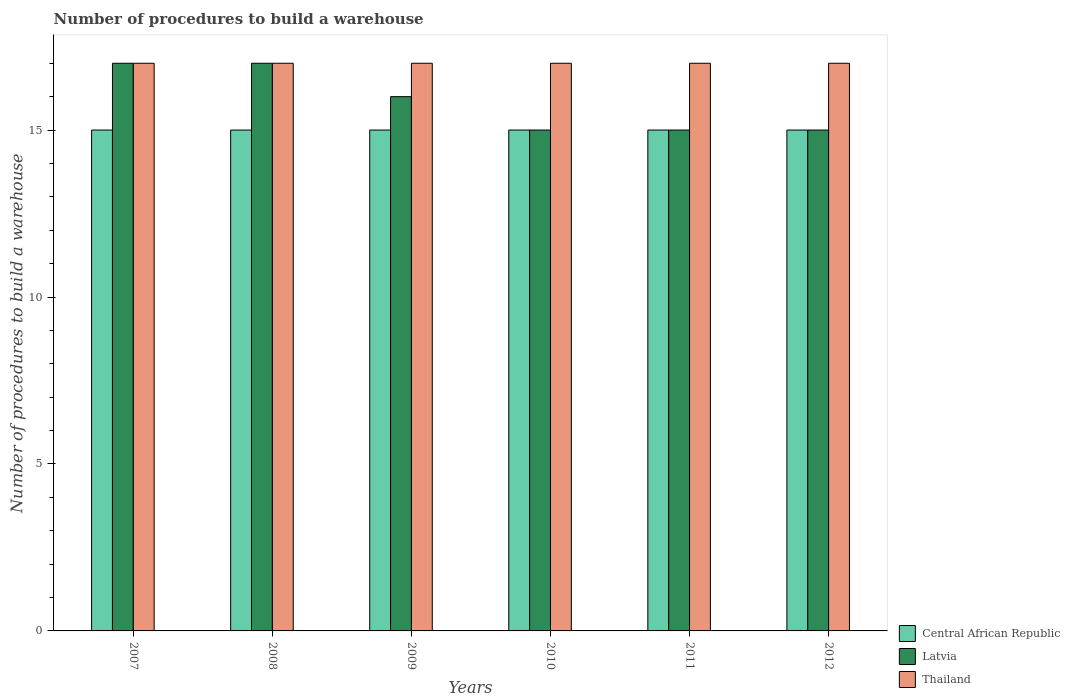How many groups of bars are there?
Ensure brevity in your answer.  6. How many bars are there on the 3rd tick from the left?
Provide a short and direct response. 3. In how many cases, is the number of bars for a given year not equal to the number of legend labels?
Offer a very short reply. 0. What is the number of procedures to build a warehouse in in Thailand in 2008?
Provide a succinct answer. 17. Across all years, what is the maximum number of procedures to build a warehouse in in Central African Republic?
Your answer should be very brief. 15. Across all years, what is the minimum number of procedures to build a warehouse in in Latvia?
Keep it short and to the point. 15. In which year was the number of procedures to build a warehouse in in Central African Republic maximum?
Provide a succinct answer. 2007. What is the total number of procedures to build a warehouse in in Central African Republic in the graph?
Your answer should be very brief. 90. What is the difference between the number of procedures to build a warehouse in in Thailand in 2007 and that in 2009?
Give a very brief answer. 0. What is the difference between the number of procedures to build a warehouse in in Latvia in 2011 and the number of procedures to build a warehouse in in Thailand in 2010?
Make the answer very short. -2. What is the average number of procedures to build a warehouse in in Latvia per year?
Provide a succinct answer. 15.83. In the year 2012, what is the difference between the number of procedures to build a warehouse in in Thailand and number of procedures to build a warehouse in in Latvia?
Make the answer very short. 2. Is the number of procedures to build a warehouse in in Latvia in 2008 less than that in 2009?
Give a very brief answer. No. Is the difference between the number of procedures to build a warehouse in in Thailand in 2011 and 2012 greater than the difference between the number of procedures to build a warehouse in in Latvia in 2011 and 2012?
Your answer should be very brief. No. What is the difference between the highest and the second highest number of procedures to build a warehouse in in Thailand?
Ensure brevity in your answer.  0. What is the difference between the highest and the lowest number of procedures to build a warehouse in in Thailand?
Offer a terse response. 0. What does the 3rd bar from the left in 2009 represents?
Your answer should be compact. Thailand. What does the 1st bar from the right in 2007 represents?
Ensure brevity in your answer.  Thailand. Is it the case that in every year, the sum of the number of procedures to build a warehouse in in Thailand and number of procedures to build a warehouse in in Central African Republic is greater than the number of procedures to build a warehouse in in Latvia?
Your answer should be compact. Yes. How many bars are there?
Offer a very short reply. 18. Are all the bars in the graph horizontal?
Ensure brevity in your answer.  No. Are the values on the major ticks of Y-axis written in scientific E-notation?
Your answer should be very brief. No. Where does the legend appear in the graph?
Make the answer very short. Bottom right. How many legend labels are there?
Provide a succinct answer. 3. What is the title of the graph?
Provide a short and direct response. Number of procedures to build a warehouse. What is the label or title of the Y-axis?
Make the answer very short. Number of procedures to build a warehouse. What is the Number of procedures to build a warehouse of Central African Republic in 2007?
Keep it short and to the point. 15. What is the Number of procedures to build a warehouse in Thailand in 2007?
Give a very brief answer. 17. What is the Number of procedures to build a warehouse in Central African Republic in 2009?
Provide a short and direct response. 15. What is the Number of procedures to build a warehouse in Thailand in 2009?
Make the answer very short. 17. What is the Number of procedures to build a warehouse in Latvia in 2011?
Ensure brevity in your answer.  15. What is the Number of procedures to build a warehouse of Thailand in 2011?
Keep it short and to the point. 17. What is the Number of procedures to build a warehouse in Latvia in 2012?
Provide a succinct answer. 15. What is the Number of procedures to build a warehouse in Thailand in 2012?
Ensure brevity in your answer.  17. Across all years, what is the maximum Number of procedures to build a warehouse of Central African Republic?
Provide a succinct answer. 15. Across all years, what is the minimum Number of procedures to build a warehouse in Thailand?
Your answer should be very brief. 17. What is the total Number of procedures to build a warehouse in Central African Republic in the graph?
Provide a succinct answer. 90. What is the total Number of procedures to build a warehouse of Latvia in the graph?
Give a very brief answer. 95. What is the total Number of procedures to build a warehouse in Thailand in the graph?
Ensure brevity in your answer.  102. What is the difference between the Number of procedures to build a warehouse in Latvia in 2007 and that in 2008?
Give a very brief answer. 0. What is the difference between the Number of procedures to build a warehouse in Thailand in 2007 and that in 2008?
Keep it short and to the point. 0. What is the difference between the Number of procedures to build a warehouse of Central African Republic in 2007 and that in 2009?
Offer a terse response. 0. What is the difference between the Number of procedures to build a warehouse in Latvia in 2007 and that in 2009?
Your answer should be very brief. 1. What is the difference between the Number of procedures to build a warehouse in Central African Republic in 2007 and that in 2010?
Ensure brevity in your answer.  0. What is the difference between the Number of procedures to build a warehouse of Latvia in 2007 and that in 2010?
Make the answer very short. 2. What is the difference between the Number of procedures to build a warehouse of Central African Republic in 2007 and that in 2011?
Provide a succinct answer. 0. What is the difference between the Number of procedures to build a warehouse of Thailand in 2007 and that in 2011?
Provide a succinct answer. 0. What is the difference between the Number of procedures to build a warehouse of Thailand in 2007 and that in 2012?
Your answer should be very brief. 0. What is the difference between the Number of procedures to build a warehouse of Latvia in 2008 and that in 2009?
Make the answer very short. 1. What is the difference between the Number of procedures to build a warehouse in Latvia in 2008 and that in 2011?
Keep it short and to the point. 2. What is the difference between the Number of procedures to build a warehouse in Latvia in 2008 and that in 2012?
Offer a terse response. 2. What is the difference between the Number of procedures to build a warehouse in Thailand in 2008 and that in 2012?
Provide a succinct answer. 0. What is the difference between the Number of procedures to build a warehouse in Latvia in 2009 and that in 2010?
Give a very brief answer. 1. What is the difference between the Number of procedures to build a warehouse in Thailand in 2009 and that in 2010?
Your response must be concise. 0. What is the difference between the Number of procedures to build a warehouse in Central African Republic in 2009 and that in 2011?
Offer a terse response. 0. What is the difference between the Number of procedures to build a warehouse in Thailand in 2009 and that in 2011?
Offer a very short reply. 0. What is the difference between the Number of procedures to build a warehouse in Latvia in 2009 and that in 2012?
Keep it short and to the point. 1. What is the difference between the Number of procedures to build a warehouse in Thailand in 2009 and that in 2012?
Offer a very short reply. 0. What is the difference between the Number of procedures to build a warehouse in Latvia in 2010 and that in 2011?
Your answer should be compact. 0. What is the difference between the Number of procedures to build a warehouse of Central African Republic in 2011 and that in 2012?
Offer a terse response. 0. What is the difference between the Number of procedures to build a warehouse in Latvia in 2011 and that in 2012?
Make the answer very short. 0. What is the difference between the Number of procedures to build a warehouse of Central African Republic in 2007 and the Number of procedures to build a warehouse of Thailand in 2008?
Offer a very short reply. -2. What is the difference between the Number of procedures to build a warehouse in Latvia in 2007 and the Number of procedures to build a warehouse in Thailand in 2009?
Give a very brief answer. 0. What is the difference between the Number of procedures to build a warehouse of Central African Republic in 2007 and the Number of procedures to build a warehouse of Latvia in 2011?
Offer a terse response. 0. What is the difference between the Number of procedures to build a warehouse of Central African Republic in 2007 and the Number of procedures to build a warehouse of Thailand in 2012?
Your response must be concise. -2. What is the difference between the Number of procedures to build a warehouse of Central African Republic in 2008 and the Number of procedures to build a warehouse of Latvia in 2009?
Your answer should be compact. -1. What is the difference between the Number of procedures to build a warehouse of Central African Republic in 2008 and the Number of procedures to build a warehouse of Thailand in 2009?
Offer a very short reply. -2. What is the difference between the Number of procedures to build a warehouse in Central African Republic in 2008 and the Number of procedures to build a warehouse in Latvia in 2010?
Offer a terse response. 0. What is the difference between the Number of procedures to build a warehouse of Central African Republic in 2008 and the Number of procedures to build a warehouse of Thailand in 2010?
Make the answer very short. -2. What is the difference between the Number of procedures to build a warehouse of Latvia in 2008 and the Number of procedures to build a warehouse of Thailand in 2010?
Make the answer very short. 0. What is the difference between the Number of procedures to build a warehouse in Latvia in 2008 and the Number of procedures to build a warehouse in Thailand in 2011?
Your response must be concise. 0. What is the difference between the Number of procedures to build a warehouse of Latvia in 2008 and the Number of procedures to build a warehouse of Thailand in 2012?
Provide a succinct answer. 0. What is the difference between the Number of procedures to build a warehouse in Central African Republic in 2009 and the Number of procedures to build a warehouse in Latvia in 2012?
Your answer should be very brief. 0. What is the difference between the Number of procedures to build a warehouse in Latvia in 2009 and the Number of procedures to build a warehouse in Thailand in 2012?
Make the answer very short. -1. What is the difference between the Number of procedures to build a warehouse of Latvia in 2010 and the Number of procedures to build a warehouse of Thailand in 2011?
Your answer should be very brief. -2. What is the difference between the Number of procedures to build a warehouse in Central African Republic in 2010 and the Number of procedures to build a warehouse in Latvia in 2012?
Ensure brevity in your answer.  0. What is the difference between the Number of procedures to build a warehouse of Central African Republic in 2011 and the Number of procedures to build a warehouse of Latvia in 2012?
Keep it short and to the point. 0. What is the difference between the Number of procedures to build a warehouse of Latvia in 2011 and the Number of procedures to build a warehouse of Thailand in 2012?
Give a very brief answer. -2. What is the average Number of procedures to build a warehouse of Latvia per year?
Offer a very short reply. 15.83. What is the average Number of procedures to build a warehouse of Thailand per year?
Your answer should be very brief. 17. In the year 2007, what is the difference between the Number of procedures to build a warehouse in Central African Republic and Number of procedures to build a warehouse in Latvia?
Provide a succinct answer. -2. In the year 2009, what is the difference between the Number of procedures to build a warehouse of Latvia and Number of procedures to build a warehouse of Thailand?
Offer a very short reply. -1. In the year 2011, what is the difference between the Number of procedures to build a warehouse in Central African Republic and Number of procedures to build a warehouse in Latvia?
Your response must be concise. 0. In the year 2011, what is the difference between the Number of procedures to build a warehouse in Central African Republic and Number of procedures to build a warehouse in Thailand?
Give a very brief answer. -2. In the year 2011, what is the difference between the Number of procedures to build a warehouse of Latvia and Number of procedures to build a warehouse of Thailand?
Provide a succinct answer. -2. In the year 2012, what is the difference between the Number of procedures to build a warehouse in Central African Republic and Number of procedures to build a warehouse in Latvia?
Give a very brief answer. 0. In the year 2012, what is the difference between the Number of procedures to build a warehouse of Latvia and Number of procedures to build a warehouse of Thailand?
Ensure brevity in your answer.  -2. What is the ratio of the Number of procedures to build a warehouse of Central African Republic in 2007 to that in 2008?
Provide a short and direct response. 1. What is the ratio of the Number of procedures to build a warehouse in Latvia in 2007 to that in 2008?
Your response must be concise. 1. What is the ratio of the Number of procedures to build a warehouse of Thailand in 2007 to that in 2008?
Ensure brevity in your answer.  1. What is the ratio of the Number of procedures to build a warehouse of Latvia in 2007 to that in 2009?
Your answer should be compact. 1.06. What is the ratio of the Number of procedures to build a warehouse in Thailand in 2007 to that in 2009?
Offer a terse response. 1. What is the ratio of the Number of procedures to build a warehouse in Central African Republic in 2007 to that in 2010?
Offer a very short reply. 1. What is the ratio of the Number of procedures to build a warehouse in Latvia in 2007 to that in 2010?
Provide a short and direct response. 1.13. What is the ratio of the Number of procedures to build a warehouse in Thailand in 2007 to that in 2010?
Your answer should be compact. 1. What is the ratio of the Number of procedures to build a warehouse in Central African Republic in 2007 to that in 2011?
Give a very brief answer. 1. What is the ratio of the Number of procedures to build a warehouse in Latvia in 2007 to that in 2011?
Make the answer very short. 1.13. What is the ratio of the Number of procedures to build a warehouse in Latvia in 2007 to that in 2012?
Your answer should be compact. 1.13. What is the ratio of the Number of procedures to build a warehouse in Thailand in 2007 to that in 2012?
Offer a very short reply. 1. What is the ratio of the Number of procedures to build a warehouse in Latvia in 2008 to that in 2010?
Your answer should be compact. 1.13. What is the ratio of the Number of procedures to build a warehouse in Latvia in 2008 to that in 2011?
Keep it short and to the point. 1.13. What is the ratio of the Number of procedures to build a warehouse of Thailand in 2008 to that in 2011?
Make the answer very short. 1. What is the ratio of the Number of procedures to build a warehouse of Latvia in 2008 to that in 2012?
Provide a succinct answer. 1.13. What is the ratio of the Number of procedures to build a warehouse of Thailand in 2008 to that in 2012?
Offer a very short reply. 1. What is the ratio of the Number of procedures to build a warehouse of Latvia in 2009 to that in 2010?
Your response must be concise. 1.07. What is the ratio of the Number of procedures to build a warehouse of Central African Republic in 2009 to that in 2011?
Keep it short and to the point. 1. What is the ratio of the Number of procedures to build a warehouse in Latvia in 2009 to that in 2011?
Make the answer very short. 1.07. What is the ratio of the Number of procedures to build a warehouse in Central African Republic in 2009 to that in 2012?
Provide a short and direct response. 1. What is the ratio of the Number of procedures to build a warehouse of Latvia in 2009 to that in 2012?
Make the answer very short. 1.07. What is the ratio of the Number of procedures to build a warehouse in Thailand in 2009 to that in 2012?
Keep it short and to the point. 1. What is the ratio of the Number of procedures to build a warehouse in Central African Republic in 2010 to that in 2011?
Your answer should be very brief. 1. What is the ratio of the Number of procedures to build a warehouse in Latvia in 2010 to that in 2011?
Your response must be concise. 1. What is the ratio of the Number of procedures to build a warehouse in Central African Republic in 2010 to that in 2012?
Provide a short and direct response. 1. What is the ratio of the Number of procedures to build a warehouse of Latvia in 2010 to that in 2012?
Give a very brief answer. 1. What is the ratio of the Number of procedures to build a warehouse of Thailand in 2010 to that in 2012?
Offer a terse response. 1. What is the difference between the highest and the second highest Number of procedures to build a warehouse in Central African Republic?
Give a very brief answer. 0. What is the difference between the highest and the lowest Number of procedures to build a warehouse in Central African Republic?
Your answer should be compact. 0. What is the difference between the highest and the lowest Number of procedures to build a warehouse in Thailand?
Provide a short and direct response. 0. 